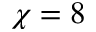<formula> <loc_0><loc_0><loc_500><loc_500>\chi = 8</formula> 